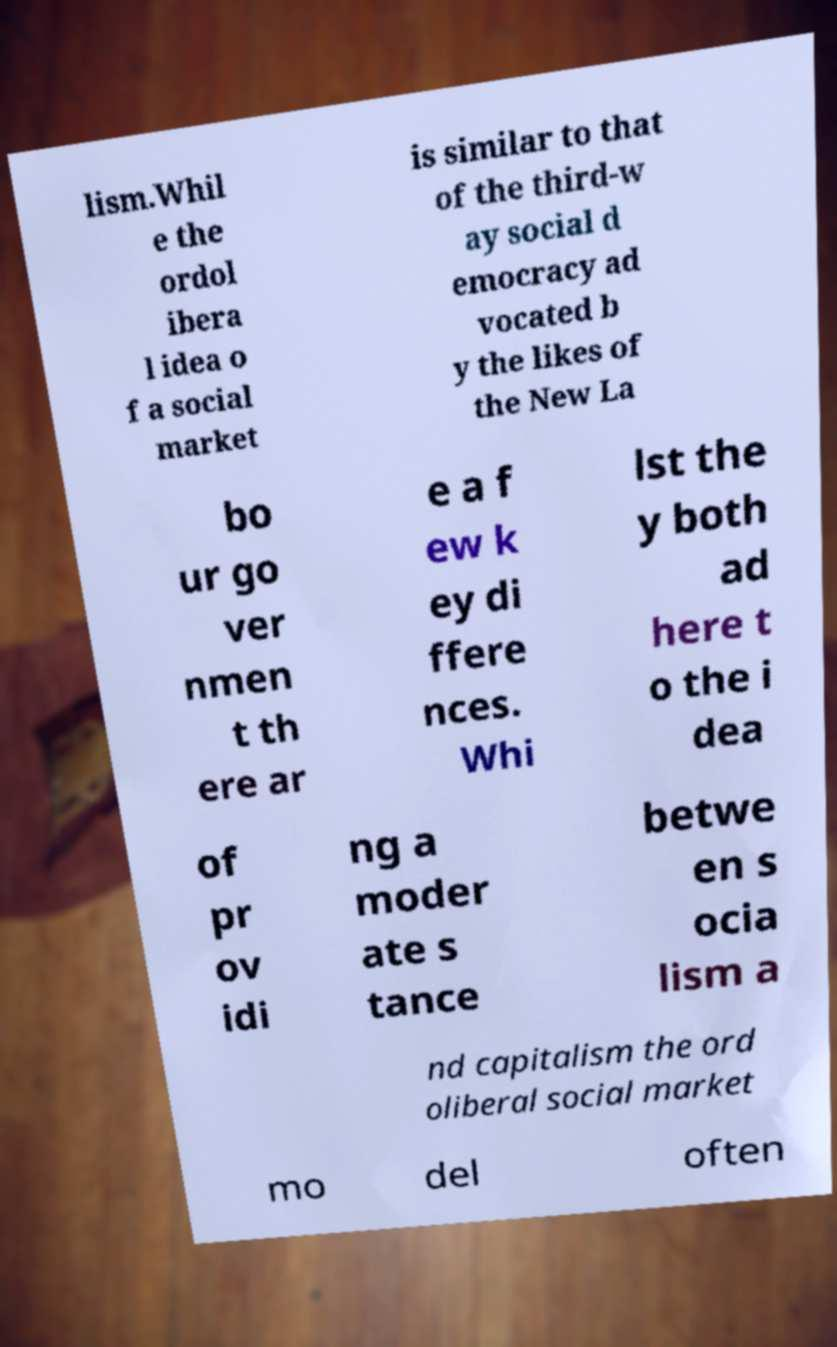I need the written content from this picture converted into text. Can you do that? lism.Whil e the ordol ibera l idea o f a social market is similar to that of the third-w ay social d emocracy ad vocated b y the likes of the New La bo ur go ver nmen t th ere ar e a f ew k ey di ffere nces. Whi lst the y both ad here t o the i dea of pr ov idi ng a moder ate s tance betwe en s ocia lism a nd capitalism the ord oliberal social market mo del often 